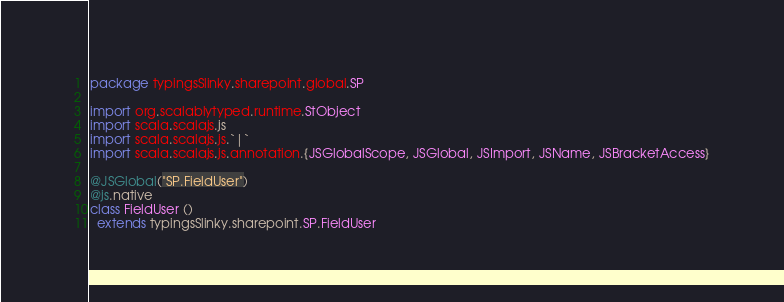Convert code to text. <code><loc_0><loc_0><loc_500><loc_500><_Scala_>package typingsSlinky.sharepoint.global.SP

import org.scalablytyped.runtime.StObject
import scala.scalajs.js
import scala.scalajs.js.`|`
import scala.scalajs.js.annotation.{JSGlobalScope, JSGlobal, JSImport, JSName, JSBracketAccess}

@JSGlobal("SP.FieldUser")
@js.native
class FieldUser ()
  extends typingsSlinky.sharepoint.SP.FieldUser
</code> 